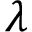<formula> <loc_0><loc_0><loc_500><loc_500>\lambda</formula> 